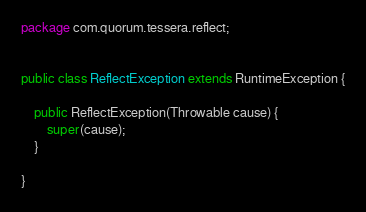Convert code to text. <code><loc_0><loc_0><loc_500><loc_500><_Java_>
package com.quorum.tessera.reflect;


public class ReflectException extends RuntimeException {

    public ReflectException(Throwable cause) {
        super(cause);
    }
    
}
</code> 